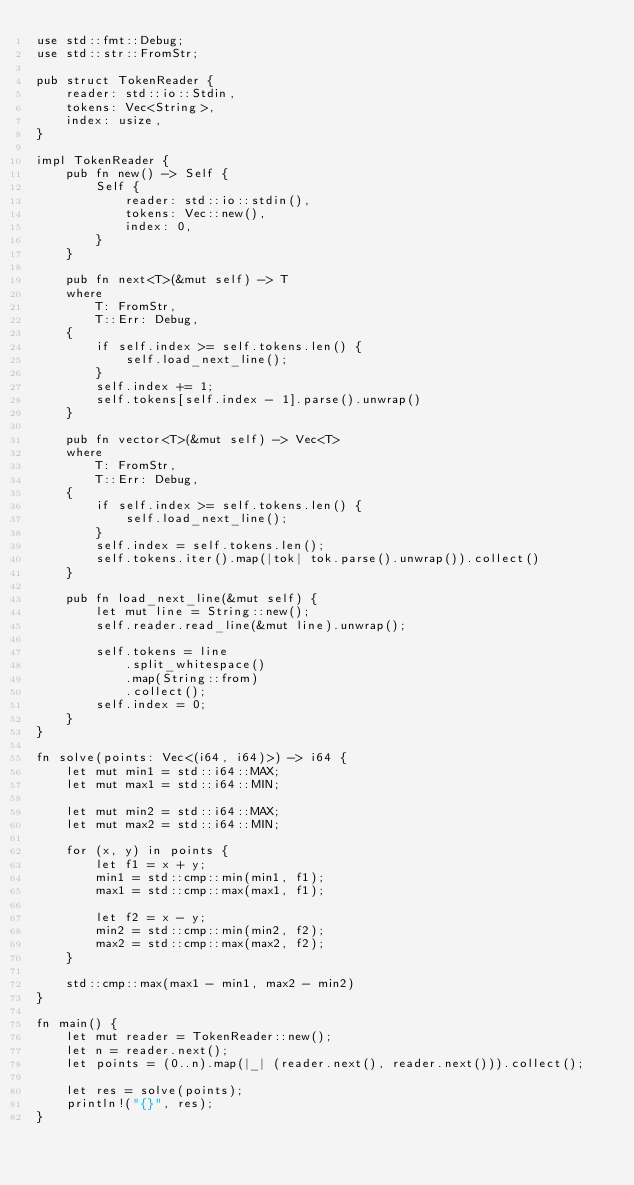Convert code to text. <code><loc_0><loc_0><loc_500><loc_500><_Rust_>use std::fmt::Debug;
use std::str::FromStr;

pub struct TokenReader {
    reader: std::io::Stdin,
    tokens: Vec<String>,
    index: usize,
}

impl TokenReader {
    pub fn new() -> Self {
        Self {
            reader: std::io::stdin(),
            tokens: Vec::new(),
            index: 0,
        }
    }

    pub fn next<T>(&mut self) -> T
    where
        T: FromStr,
        T::Err: Debug,
    {
        if self.index >= self.tokens.len() {
            self.load_next_line();
        }
        self.index += 1;
        self.tokens[self.index - 1].parse().unwrap()
    }

    pub fn vector<T>(&mut self) -> Vec<T>
    where
        T: FromStr,
        T::Err: Debug,
    {
        if self.index >= self.tokens.len() {
            self.load_next_line();
        }
        self.index = self.tokens.len();
        self.tokens.iter().map(|tok| tok.parse().unwrap()).collect()
    }

    pub fn load_next_line(&mut self) {
        let mut line = String::new();
        self.reader.read_line(&mut line).unwrap();

        self.tokens = line
            .split_whitespace()
            .map(String::from)
            .collect();
        self.index = 0;
    }
}

fn solve(points: Vec<(i64, i64)>) -> i64 {
    let mut min1 = std::i64::MAX;
    let mut max1 = std::i64::MIN;

    let mut min2 = std::i64::MAX;
    let mut max2 = std::i64::MIN;

    for (x, y) in points {
        let f1 = x + y;
        min1 = std::cmp::min(min1, f1);
        max1 = std::cmp::max(max1, f1);

        let f2 = x - y;
        min2 = std::cmp::min(min2, f2);
        max2 = std::cmp::max(max2, f2);
    }

    std::cmp::max(max1 - min1, max2 - min2)
}

fn main() {
    let mut reader = TokenReader::new();
    let n = reader.next();
    let points = (0..n).map(|_| (reader.next(), reader.next())).collect();

    let res = solve(points);
    println!("{}", res);
}
</code> 